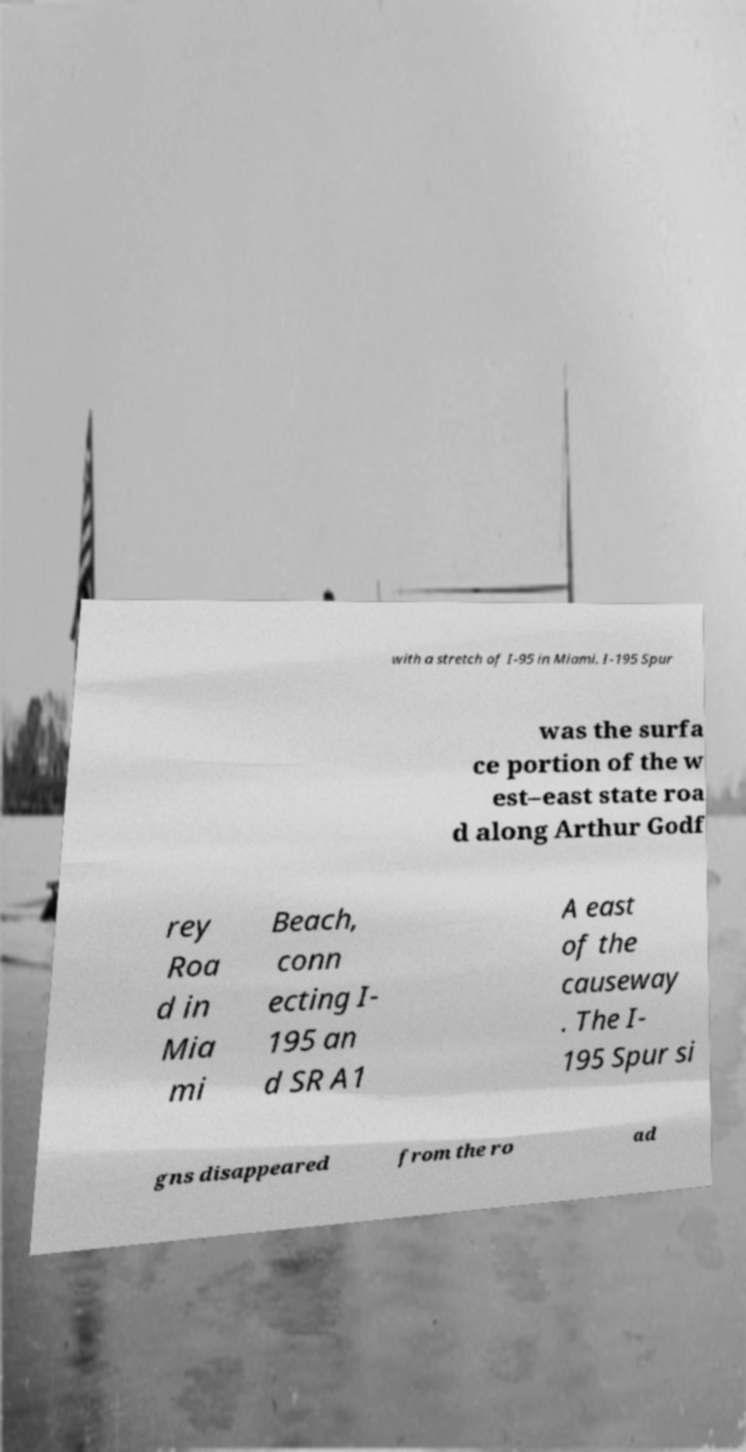Can you accurately transcribe the text from the provided image for me? with a stretch of I-95 in Miami. I-195 Spur was the surfa ce portion of the w est–east state roa d along Arthur Godf rey Roa d in Mia mi Beach, conn ecting I- 195 an d SR A1 A east of the causeway . The I- 195 Spur si gns disappeared from the ro ad 